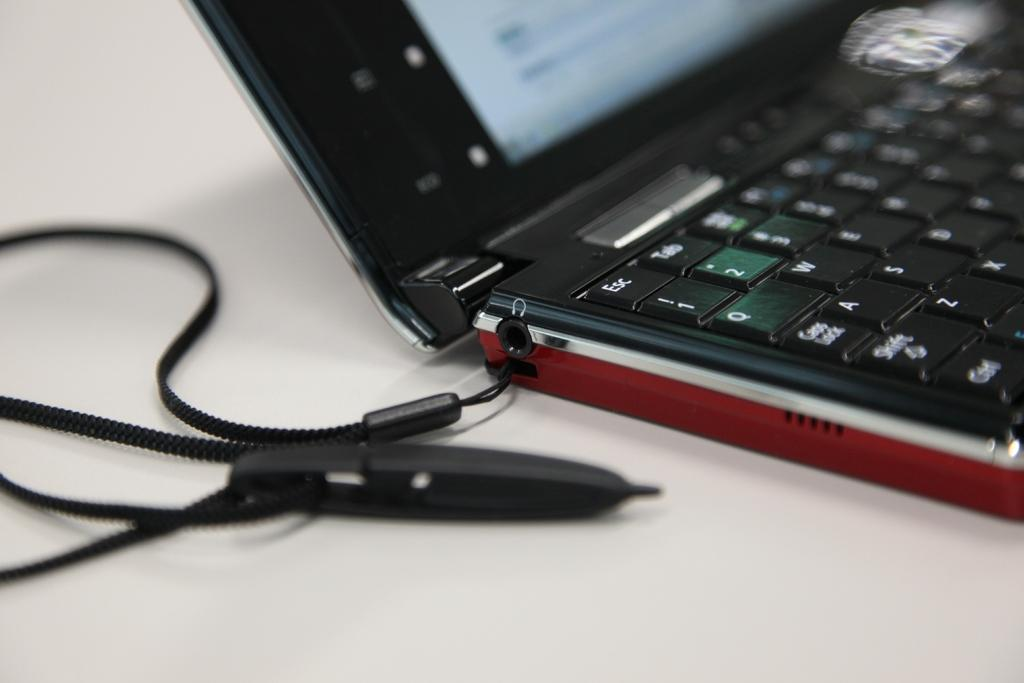What object can be seen in the image that is typically used for holding keys? There is a key chain in the image. What electronic device is present in the image? There is a laptop in the image. On what surface is the laptop placed? The laptop is placed on a white surface. How would you describe the clarity of the image? The image is blurred in some parts. What type of flowers are arranged on the loaf in the image? There are no flowers or loaf present in the image. 